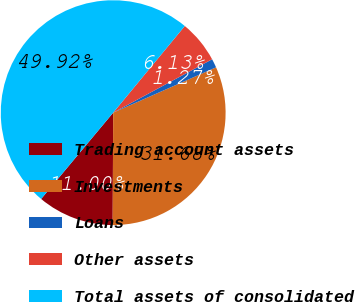Convert chart to OTSL. <chart><loc_0><loc_0><loc_500><loc_500><pie_chart><fcel>Trading account assets<fcel>Investments<fcel>Loans<fcel>Other assets<fcel>Total assets of consolidated<nl><fcel>11.0%<fcel>31.68%<fcel>1.27%<fcel>6.13%<fcel>49.92%<nl></chart> 